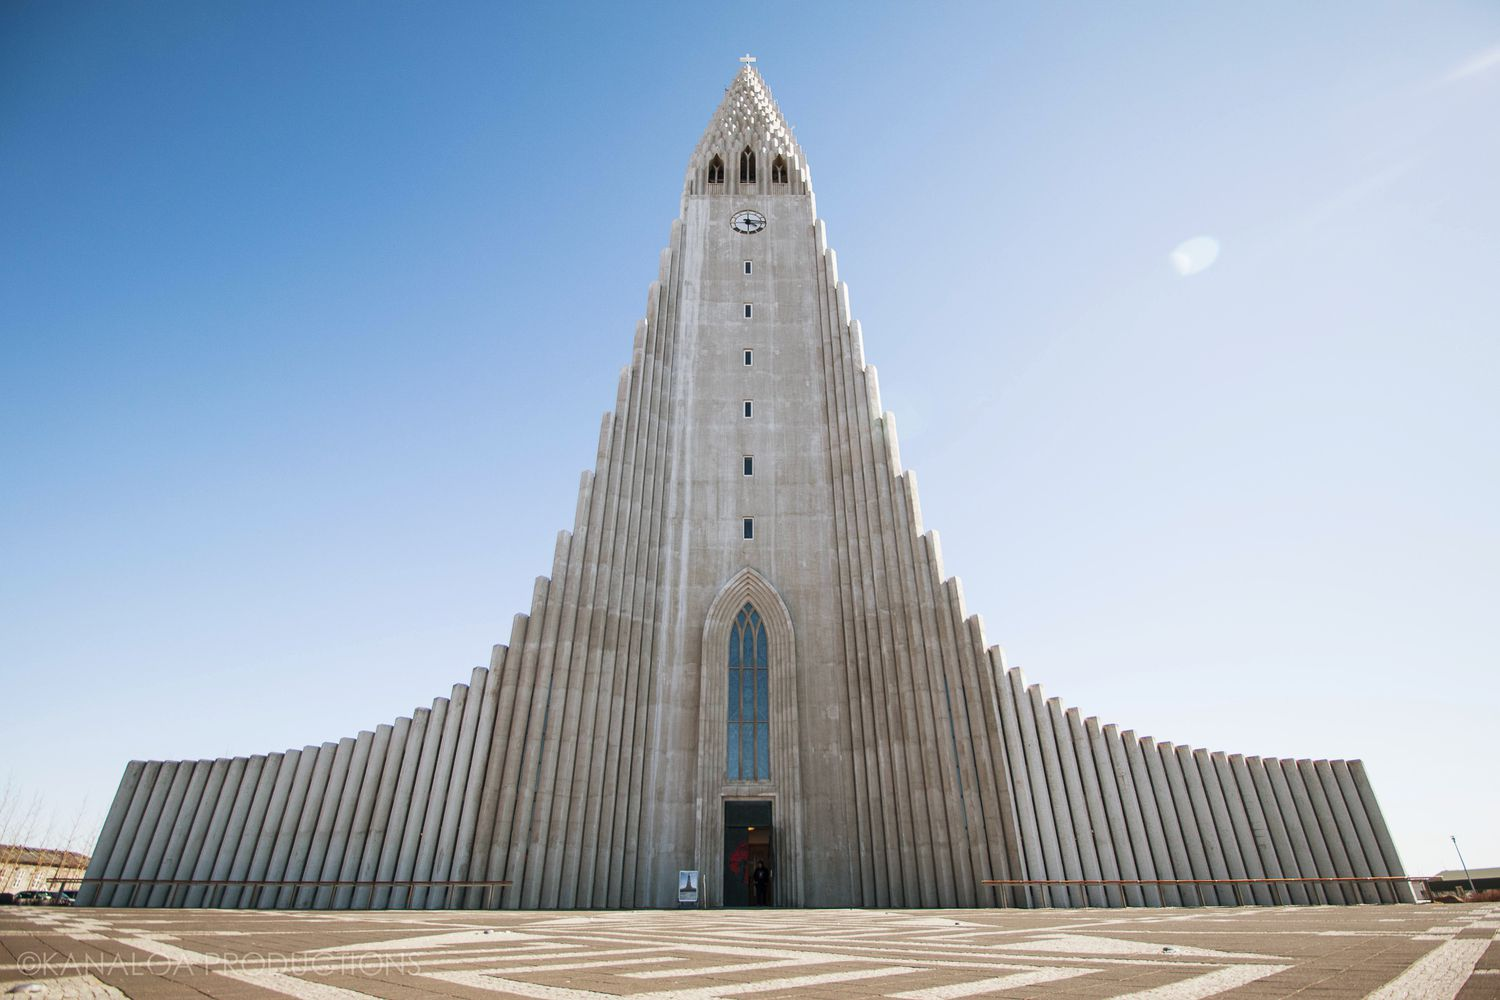Can you tell me about the architectural significance of Hallgrímskirkja? Hallgrímskirkja is architecturally significant for its unique design, inspired by the natural geology of Iceland, such as basalt columns that can be found around the black sand beaches. The church's structure, resembling an organ or a rocket ship, symbolizes reaching towards the sky, which represents spiritual aspiration. The minimalist design reflects the Icelandic aesthetic, focusing on pure, clean lines and natural light. 